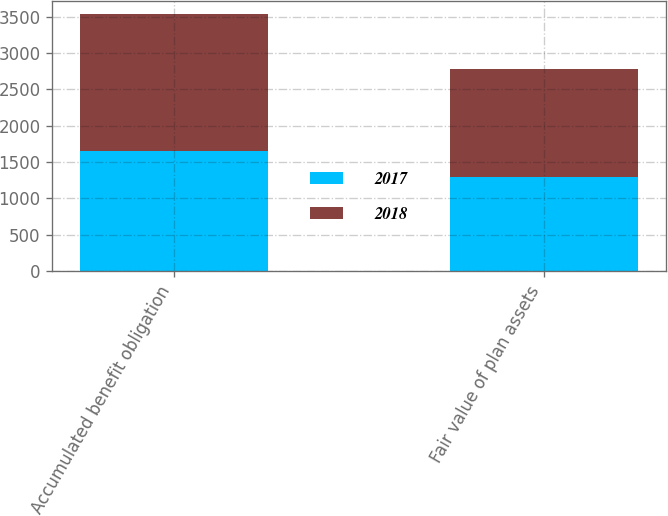Convert chart to OTSL. <chart><loc_0><loc_0><loc_500><loc_500><stacked_bar_chart><ecel><fcel>Accumulated benefit obligation<fcel>Fair value of plan assets<nl><fcel>2017<fcel>1648.9<fcel>1292.6<nl><fcel>2018<fcel>1887.1<fcel>1485.2<nl></chart> 